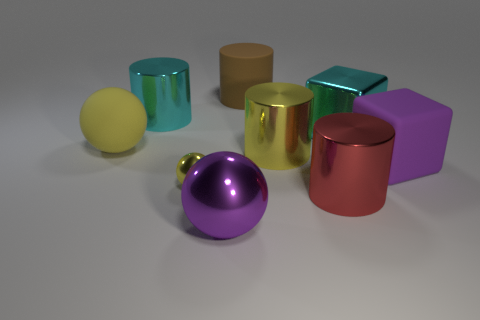Subtract 1 cylinders. How many cylinders are left? 3 Subtract all big yellow cylinders. How many cylinders are left? 3 Add 1 large yellow balls. How many objects exist? 10 Subtract all blue cylinders. Subtract all green balls. How many cylinders are left? 4 Subtract all cubes. How many objects are left? 7 Add 4 large yellow metallic cylinders. How many large yellow metallic cylinders are left? 5 Add 1 cyan rubber cylinders. How many cyan rubber cylinders exist? 1 Subtract 0 purple cylinders. How many objects are left? 9 Subtract all red metallic objects. Subtract all small purple blocks. How many objects are left? 8 